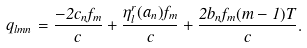Convert formula to latex. <formula><loc_0><loc_0><loc_500><loc_500>q _ { l m n } = \frac { - 2 c _ { n } f _ { m } } { c } + \frac { \eta _ { l } ^ { r } ( a _ { n } ) f _ { m } } { c } + \frac { 2 b _ { n } f _ { m } ( m - 1 ) T } { c } .</formula> 